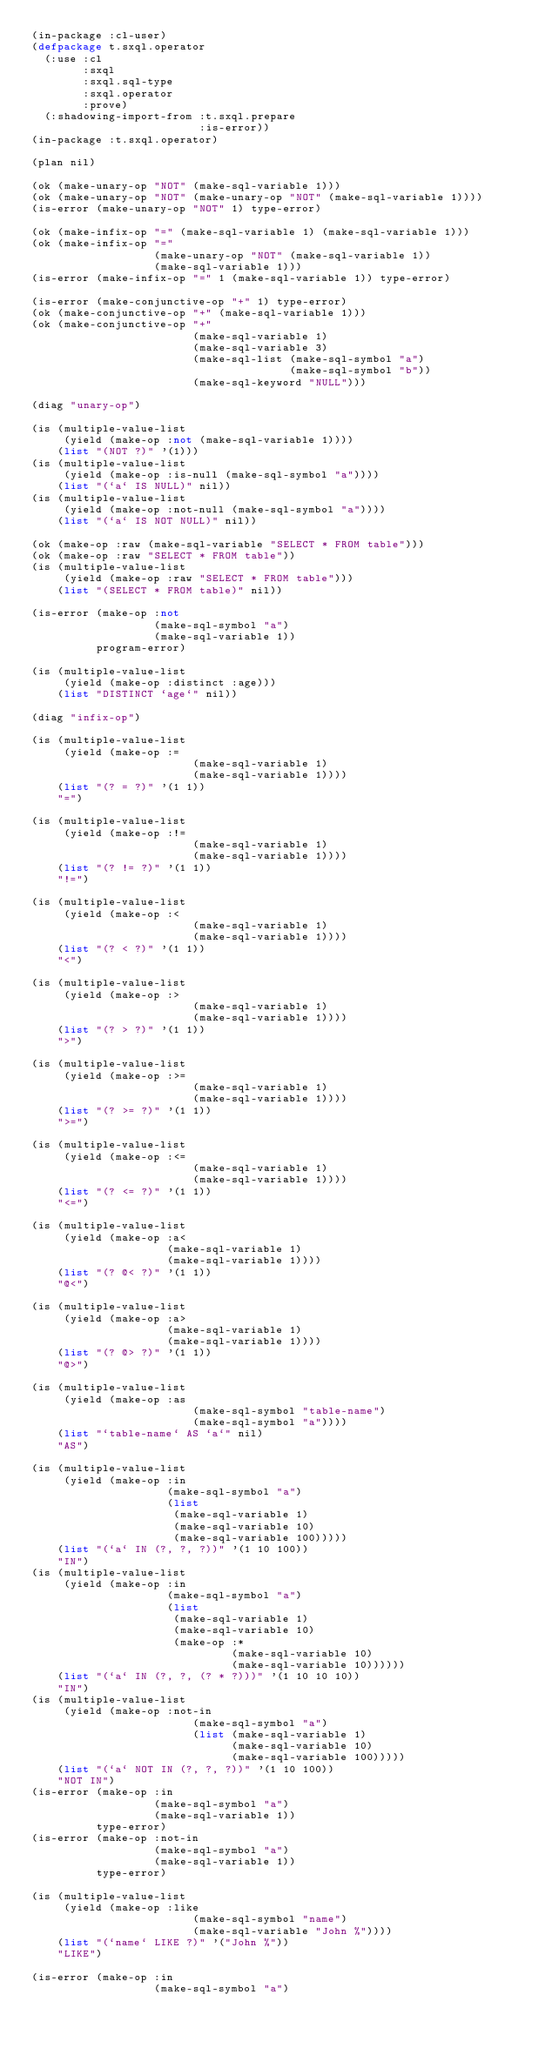Convert code to text. <code><loc_0><loc_0><loc_500><loc_500><_Lisp_>(in-package :cl-user)
(defpackage t.sxql.operator
  (:use :cl
        :sxql
        :sxql.sql-type
        :sxql.operator
        :prove)
  (:shadowing-import-from :t.sxql.prepare
                          :is-error))
(in-package :t.sxql.operator)

(plan nil)

(ok (make-unary-op "NOT" (make-sql-variable 1)))
(ok (make-unary-op "NOT" (make-unary-op "NOT" (make-sql-variable 1))))
(is-error (make-unary-op "NOT" 1) type-error)

(ok (make-infix-op "=" (make-sql-variable 1) (make-sql-variable 1)))
(ok (make-infix-op "="
                   (make-unary-op "NOT" (make-sql-variable 1))
                   (make-sql-variable 1)))
(is-error (make-infix-op "=" 1 (make-sql-variable 1)) type-error)

(is-error (make-conjunctive-op "+" 1) type-error)
(ok (make-conjunctive-op "+" (make-sql-variable 1)))
(ok (make-conjunctive-op "+"
                         (make-sql-variable 1)
                         (make-sql-variable 3)
                         (make-sql-list (make-sql-symbol "a")
                                        (make-sql-symbol "b"))
                         (make-sql-keyword "NULL")))

(diag "unary-op")

(is (multiple-value-list
     (yield (make-op :not (make-sql-variable 1))))
    (list "(NOT ?)" '(1)))
(is (multiple-value-list
     (yield (make-op :is-null (make-sql-symbol "a"))))
    (list "(`a` IS NULL)" nil))
(is (multiple-value-list
     (yield (make-op :not-null (make-sql-symbol "a"))))
    (list "(`a` IS NOT NULL)" nil))

(ok (make-op :raw (make-sql-variable "SELECT * FROM table")))
(ok (make-op :raw "SELECT * FROM table"))
(is (multiple-value-list
     (yield (make-op :raw "SELECT * FROM table")))
    (list "(SELECT * FROM table)" nil))

(is-error (make-op :not
                   (make-sql-symbol "a")
                   (make-sql-variable 1))
          program-error)

(is (multiple-value-list
     (yield (make-op :distinct :age)))
    (list "DISTINCT `age`" nil))

(diag "infix-op")

(is (multiple-value-list
     (yield (make-op :=
                         (make-sql-variable 1)
                         (make-sql-variable 1))))
    (list "(? = ?)" '(1 1))
    "=")

(is (multiple-value-list
     (yield (make-op :!=
                         (make-sql-variable 1)
                         (make-sql-variable 1))))
    (list "(? != ?)" '(1 1))
    "!=")

(is (multiple-value-list
     (yield (make-op :<
                         (make-sql-variable 1)
                         (make-sql-variable 1))))
    (list "(? < ?)" '(1 1))
    "<")

(is (multiple-value-list
     (yield (make-op :>
                         (make-sql-variable 1)
                         (make-sql-variable 1))))
    (list "(? > ?)" '(1 1))
    ">")

(is (multiple-value-list
     (yield (make-op :>=
                         (make-sql-variable 1)
                         (make-sql-variable 1))))
    (list "(? >= ?)" '(1 1))
    ">=")

(is (multiple-value-list
     (yield (make-op :<=
                         (make-sql-variable 1)
                         (make-sql-variable 1))))
    (list "(? <= ?)" '(1 1))
    "<=")

(is (multiple-value-list
     (yield (make-op :a<
                     (make-sql-variable 1)
                     (make-sql-variable 1))))
    (list "(? @< ?)" '(1 1))
    "@<")

(is (multiple-value-list
     (yield (make-op :a>
                     (make-sql-variable 1)
                     (make-sql-variable 1))))
    (list "(? @> ?)" '(1 1))
    "@>")

(is (multiple-value-list
     (yield (make-op :as
                         (make-sql-symbol "table-name")
                         (make-sql-symbol "a"))))
    (list "`table-name` AS `a`" nil)
    "AS")

(is (multiple-value-list
     (yield (make-op :in
                     (make-sql-symbol "a")
                     (list
                      (make-sql-variable 1)
                      (make-sql-variable 10)
                      (make-sql-variable 100)))))
    (list "(`a` IN (?, ?, ?))" '(1 10 100))
    "IN")
(is (multiple-value-list
     (yield (make-op :in
                     (make-sql-symbol "a")
                     (list
                      (make-sql-variable 1)
                      (make-sql-variable 10)
                      (make-op :*
                               (make-sql-variable 10)
                               (make-sql-variable 10))))))
    (list "(`a` IN (?, ?, (? * ?)))" '(1 10 10 10))
    "IN")
(is (multiple-value-list
     (yield (make-op :not-in
                         (make-sql-symbol "a")
                         (list (make-sql-variable 1)
                               (make-sql-variable 10)
                               (make-sql-variable 100)))))
    (list "(`a` NOT IN (?, ?, ?))" '(1 10 100))
    "NOT IN")
(is-error (make-op :in
                   (make-sql-symbol "a")
                   (make-sql-variable 1))
          type-error)
(is-error (make-op :not-in
                   (make-sql-symbol "a")
                   (make-sql-variable 1))
          type-error)

(is (multiple-value-list
     (yield (make-op :like
                         (make-sql-symbol "name")
                         (make-sql-variable "John %"))))
    (list "(`name` LIKE ?)" '("John %"))
    "LIKE")

(is-error (make-op :in
                   (make-sql-symbol "a")</code> 